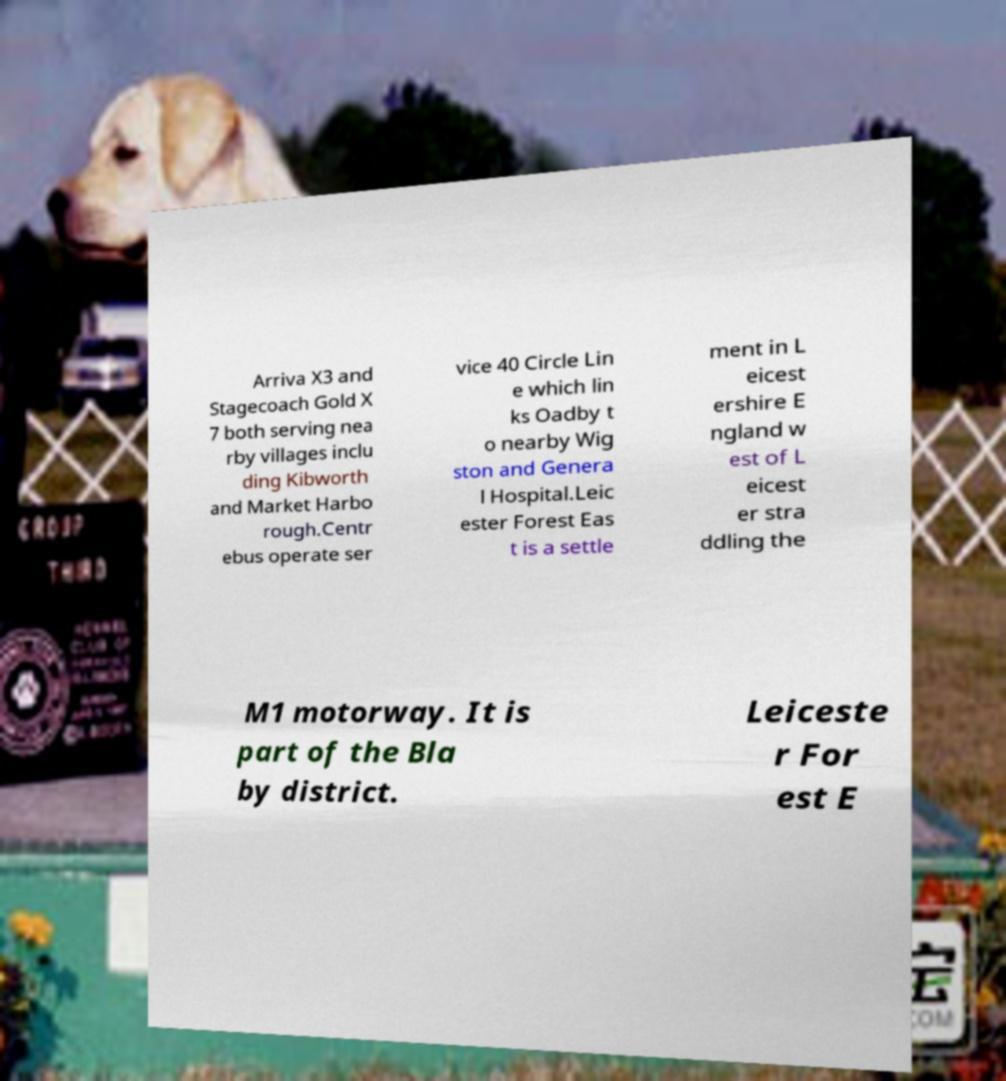For documentation purposes, I need the text within this image transcribed. Could you provide that? Arriva X3 and Stagecoach Gold X 7 both serving nea rby villages inclu ding Kibworth and Market Harbo rough.Centr ebus operate ser vice 40 Circle Lin e which lin ks Oadby t o nearby Wig ston and Genera l Hospital.Leic ester Forest Eas t is a settle ment in L eicest ershire E ngland w est of L eicest er stra ddling the M1 motorway. It is part of the Bla by district. Leiceste r For est E 